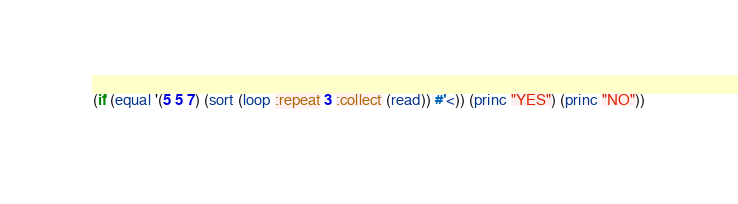<code> <loc_0><loc_0><loc_500><loc_500><_Lisp_>(if (equal '(5 5 7) (sort (loop :repeat 3 :collect (read)) #'<)) (princ "YES") (princ "NO"))</code> 